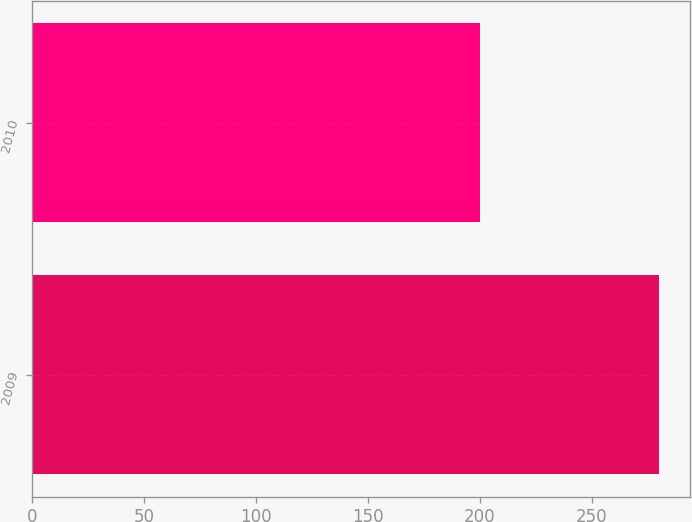Convert chart to OTSL. <chart><loc_0><loc_0><loc_500><loc_500><bar_chart><fcel>2009<fcel>2010<nl><fcel>280<fcel>200<nl></chart> 